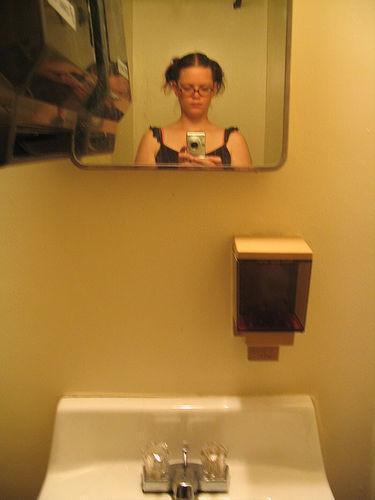How many people are in the photo?
Give a very brief answer. 1. 